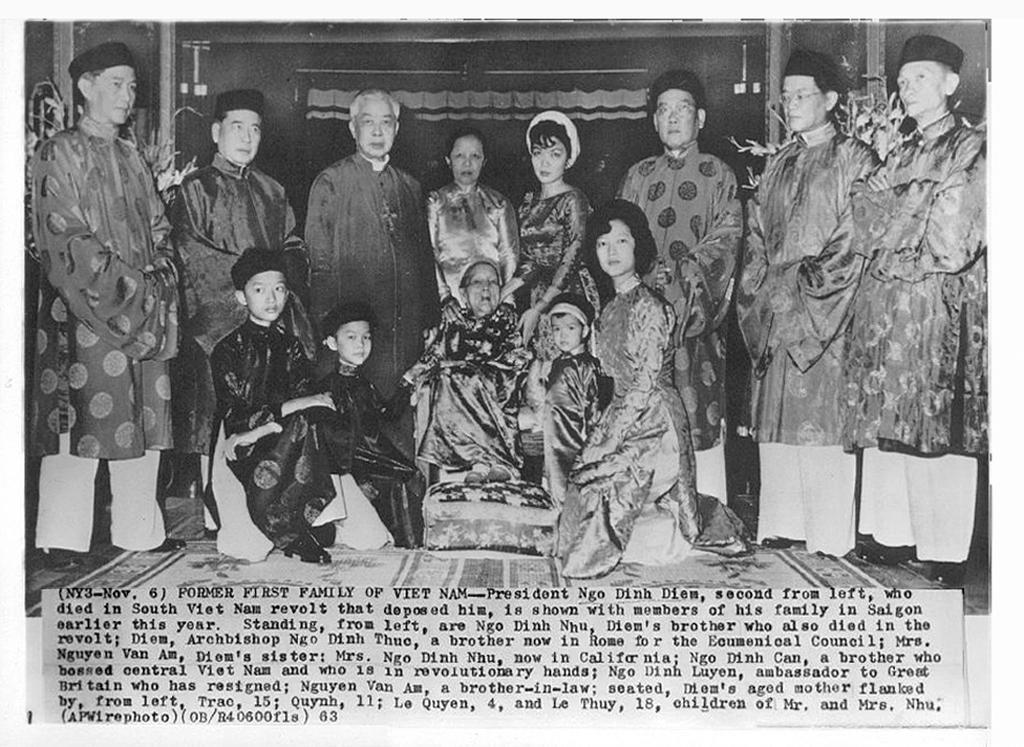Could you give a brief overview of what you see in this image? This is a black and white image. In this image there are many people. Some are wearing caps. At the bottom of the image something is written. 